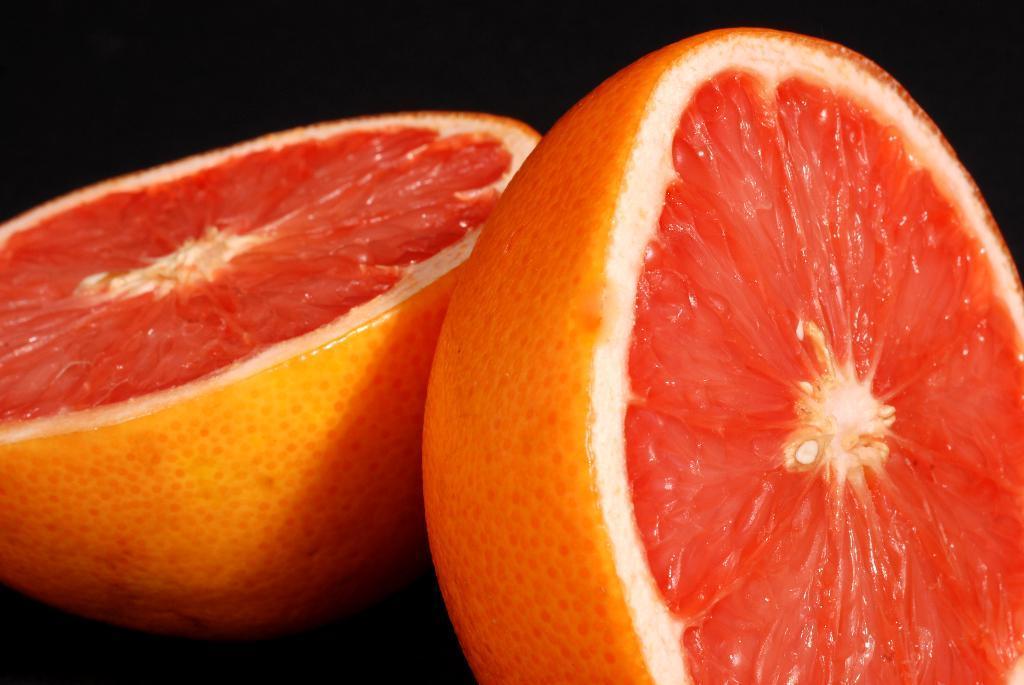Can you describe this image briefly? In this image we can see a orange which is sliced into two pieces. 